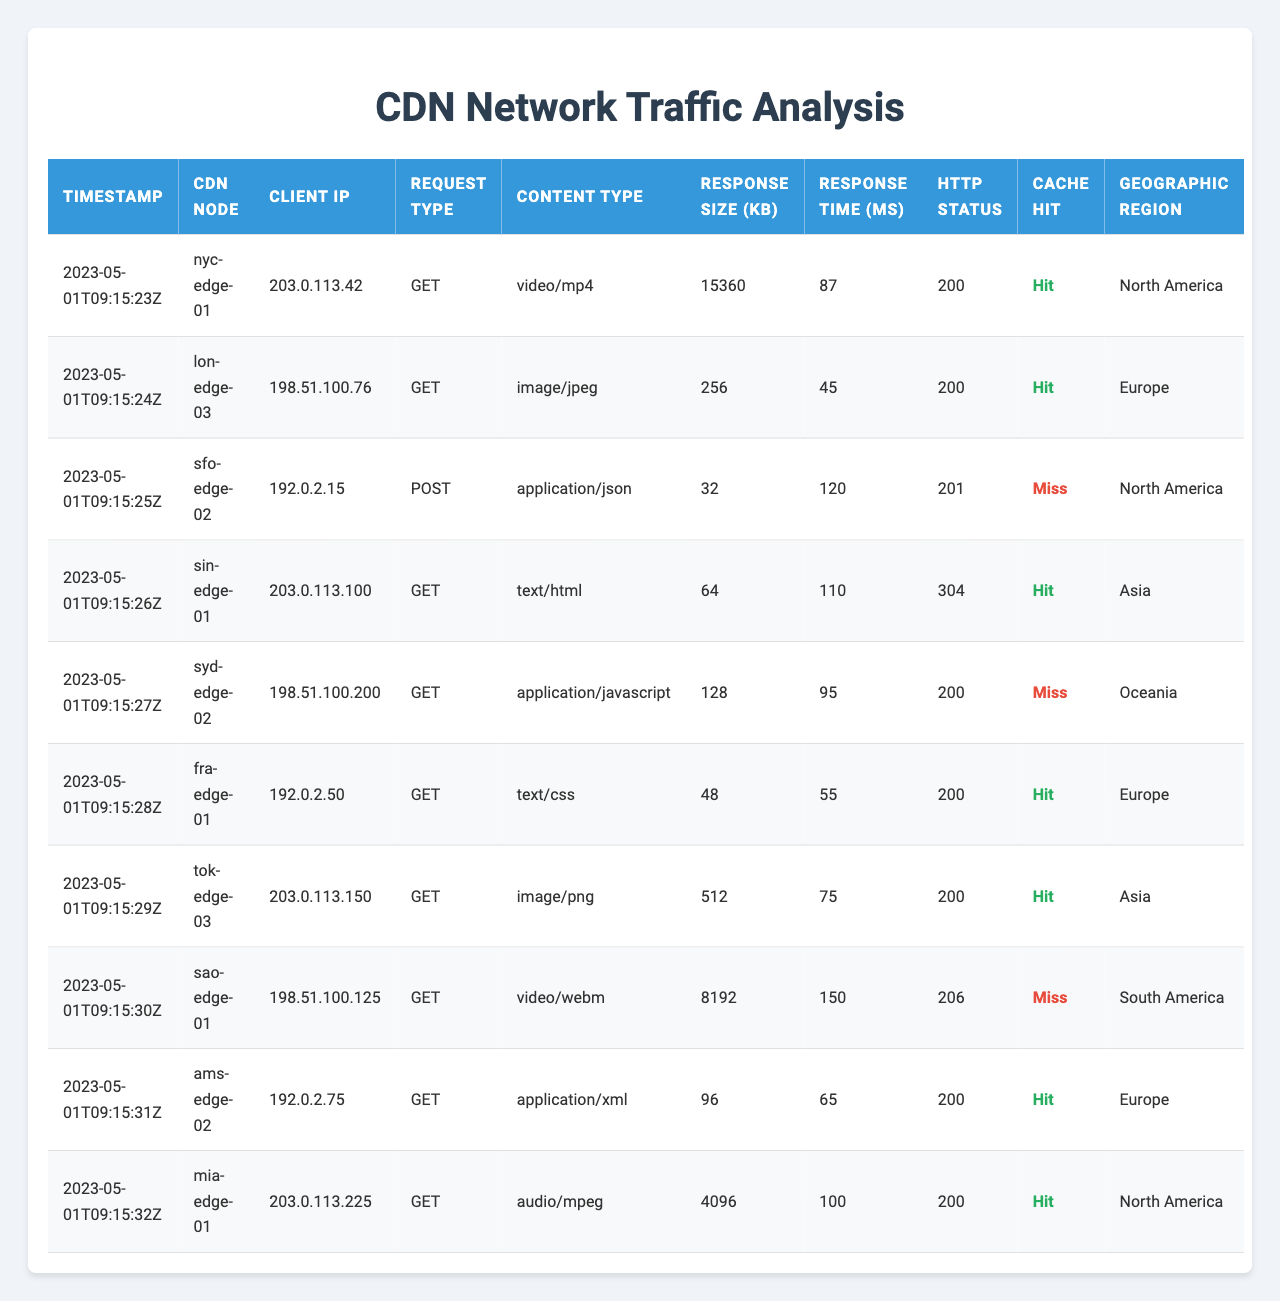What is the HTTP status of the request from the client IP 203.0.113.42? Referring to the table, the request from client IP 203.0.113.42 has an HTTP status of 200.
Answer: 200 Which CDN node had the highest response size and what was that size? In the table, the entry from the CDN node "nyc-edge-01" has the highest response size of 15360 KB.
Answer: 15360 KB How many requests resulted in a cache miss? There are two entries in the table where the Cache Hit value is false, indicating a cache miss.
Answer: 2 What is the average response time for all requests? To find the average response time, sum the response times (87 + 45 + 120 + 110 + 95 + 55 + 75 + 150 + 65 + 100 = 1027) and divide by the number of requests (10). Therefore, the average response time is 1027/10 = 102.7 ms.
Answer: 102.7 ms Did any requests from Asia result in a cache miss? Checking the table, there are two requests from Asia: one from "sin-edge-01" with a cache hit and one from "tok-edge-03" with a cache hit; thus, there are no cache misses from Asia.
Answer: No Which content type had the fastest response time, and what was the time? Reviewing the table, the request for "image/jpeg" from "lon-edge-03" has the fastest response time of 45 ms.
Answer: 45 ms What percentage of the requests resulted in a cache hit? There are 8 cache hits out of 10 total requests. To find the percentage, (8 / 10) * 100 = 80%.
Answer: 80% Which geographic region has the most requests listed? The geographic regions listed are North America (3), Europe (4), Asia (2), Oceania (1), and South America (1). Europe has the most requests with 4 entries.
Answer: Europe What is the total response size of all requests that were made with a GET type? Summing the response sizes of all GET requests (15360 + 256 + 64 + 128 + 48 + 512 + 96 + 4096 = 20264 KB) gives the total response size for GET requests.
Answer: 20264 KB Was there any POST request that did not hit the cache? Looking at the table entry for the POST request, it shows "false" for cache hit, confirming that the POST request did not hit the cache.
Answer: Yes 